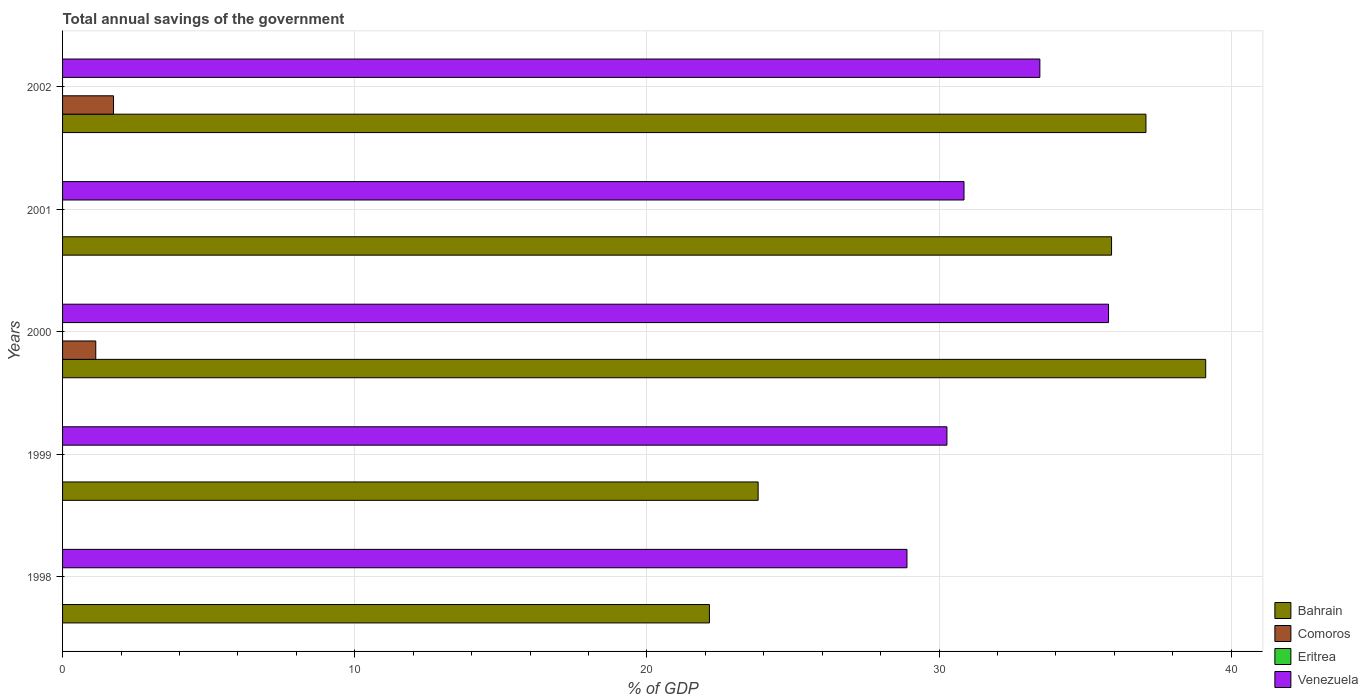How many different coloured bars are there?
Give a very brief answer. 3. How many groups of bars are there?
Your answer should be compact. 5. How many bars are there on the 4th tick from the bottom?
Ensure brevity in your answer.  2. What is the label of the 5th group of bars from the top?
Your answer should be very brief. 1998. In how many cases, is the number of bars for a given year not equal to the number of legend labels?
Your response must be concise. 5. What is the total annual savings of the government in Comoros in 2002?
Keep it short and to the point. 1.74. Across all years, what is the maximum total annual savings of the government in Comoros?
Give a very brief answer. 1.74. What is the total total annual savings of the government in Venezuela in the graph?
Provide a succinct answer. 159.28. What is the difference between the total annual savings of the government in Venezuela in 1998 and that in 2002?
Offer a very short reply. -4.55. What is the difference between the total annual savings of the government in Comoros in 1998 and the total annual savings of the government in Venezuela in 2002?
Provide a succinct answer. -33.45. What is the average total annual savings of the government in Bahrain per year?
Offer a terse response. 31.61. In the year 2000, what is the difference between the total annual savings of the government in Comoros and total annual savings of the government in Venezuela?
Offer a terse response. -34.67. In how many years, is the total annual savings of the government in Venezuela greater than 20 %?
Provide a short and direct response. 5. What is the ratio of the total annual savings of the government in Bahrain in 1998 to that in 2000?
Your answer should be compact. 0.57. What is the difference between the highest and the second highest total annual savings of the government in Bahrain?
Provide a short and direct response. 2.05. What is the difference between the highest and the lowest total annual savings of the government in Venezuela?
Make the answer very short. 6.9. In how many years, is the total annual savings of the government in Comoros greater than the average total annual savings of the government in Comoros taken over all years?
Give a very brief answer. 2. Is it the case that in every year, the sum of the total annual savings of the government in Comoros and total annual savings of the government in Eritrea is greater than the sum of total annual savings of the government in Bahrain and total annual savings of the government in Venezuela?
Offer a terse response. No. How many bars are there?
Offer a terse response. 12. How many years are there in the graph?
Your answer should be very brief. 5. Does the graph contain any zero values?
Keep it short and to the point. Yes. Does the graph contain grids?
Offer a terse response. Yes. Where does the legend appear in the graph?
Keep it short and to the point. Bottom right. How are the legend labels stacked?
Your response must be concise. Vertical. What is the title of the graph?
Your answer should be very brief. Total annual savings of the government. Does "Central Europe" appear as one of the legend labels in the graph?
Give a very brief answer. No. What is the label or title of the X-axis?
Offer a very short reply. % of GDP. What is the % of GDP in Bahrain in 1998?
Provide a short and direct response. 22.14. What is the % of GDP in Comoros in 1998?
Offer a terse response. 0. What is the % of GDP of Venezuela in 1998?
Your answer should be compact. 28.9. What is the % of GDP of Bahrain in 1999?
Provide a succinct answer. 23.81. What is the % of GDP in Comoros in 1999?
Offer a very short reply. 0. What is the % of GDP of Eritrea in 1999?
Your response must be concise. 0. What is the % of GDP in Venezuela in 1999?
Give a very brief answer. 30.27. What is the % of GDP of Bahrain in 2000?
Offer a terse response. 39.13. What is the % of GDP of Comoros in 2000?
Your answer should be very brief. 1.14. What is the % of GDP of Eritrea in 2000?
Your response must be concise. 0. What is the % of GDP in Venezuela in 2000?
Your answer should be compact. 35.8. What is the % of GDP of Bahrain in 2001?
Give a very brief answer. 35.9. What is the % of GDP of Eritrea in 2001?
Offer a very short reply. 0. What is the % of GDP in Venezuela in 2001?
Provide a succinct answer. 30.85. What is the % of GDP of Bahrain in 2002?
Ensure brevity in your answer.  37.08. What is the % of GDP in Comoros in 2002?
Offer a very short reply. 1.74. What is the % of GDP in Venezuela in 2002?
Your response must be concise. 33.45. Across all years, what is the maximum % of GDP of Bahrain?
Provide a short and direct response. 39.13. Across all years, what is the maximum % of GDP in Comoros?
Provide a short and direct response. 1.74. Across all years, what is the maximum % of GDP of Venezuela?
Ensure brevity in your answer.  35.8. Across all years, what is the minimum % of GDP in Bahrain?
Provide a succinct answer. 22.14. Across all years, what is the minimum % of GDP in Comoros?
Offer a terse response. 0. Across all years, what is the minimum % of GDP in Venezuela?
Ensure brevity in your answer.  28.9. What is the total % of GDP of Bahrain in the graph?
Provide a succinct answer. 158.06. What is the total % of GDP in Comoros in the graph?
Your answer should be compact. 2.88. What is the total % of GDP in Venezuela in the graph?
Offer a terse response. 159.28. What is the difference between the % of GDP of Bahrain in 1998 and that in 1999?
Your answer should be very brief. -1.67. What is the difference between the % of GDP of Venezuela in 1998 and that in 1999?
Your answer should be compact. -1.37. What is the difference between the % of GDP of Bahrain in 1998 and that in 2000?
Your answer should be very brief. -16.99. What is the difference between the % of GDP in Venezuela in 1998 and that in 2000?
Keep it short and to the point. -6.9. What is the difference between the % of GDP in Bahrain in 1998 and that in 2001?
Ensure brevity in your answer.  -13.76. What is the difference between the % of GDP in Venezuela in 1998 and that in 2001?
Offer a very short reply. -1.95. What is the difference between the % of GDP in Bahrain in 1998 and that in 2002?
Keep it short and to the point. -14.94. What is the difference between the % of GDP of Venezuela in 1998 and that in 2002?
Your answer should be compact. -4.55. What is the difference between the % of GDP in Bahrain in 1999 and that in 2000?
Your answer should be compact. -15.32. What is the difference between the % of GDP of Venezuela in 1999 and that in 2000?
Keep it short and to the point. -5.53. What is the difference between the % of GDP in Bahrain in 1999 and that in 2001?
Offer a very short reply. -12.1. What is the difference between the % of GDP of Venezuela in 1999 and that in 2001?
Your answer should be very brief. -0.58. What is the difference between the % of GDP of Bahrain in 1999 and that in 2002?
Your answer should be compact. -13.27. What is the difference between the % of GDP of Venezuela in 1999 and that in 2002?
Your response must be concise. -3.18. What is the difference between the % of GDP of Bahrain in 2000 and that in 2001?
Your answer should be compact. 3.22. What is the difference between the % of GDP of Venezuela in 2000 and that in 2001?
Ensure brevity in your answer.  4.95. What is the difference between the % of GDP of Bahrain in 2000 and that in 2002?
Provide a short and direct response. 2.05. What is the difference between the % of GDP of Comoros in 2000 and that in 2002?
Offer a very short reply. -0.61. What is the difference between the % of GDP in Venezuela in 2000 and that in 2002?
Provide a succinct answer. 2.35. What is the difference between the % of GDP of Bahrain in 2001 and that in 2002?
Give a very brief answer. -1.18. What is the difference between the % of GDP in Venezuela in 2001 and that in 2002?
Provide a short and direct response. -2.6. What is the difference between the % of GDP in Bahrain in 1998 and the % of GDP in Venezuela in 1999?
Give a very brief answer. -8.13. What is the difference between the % of GDP in Bahrain in 1998 and the % of GDP in Comoros in 2000?
Provide a short and direct response. 21. What is the difference between the % of GDP of Bahrain in 1998 and the % of GDP of Venezuela in 2000?
Provide a short and direct response. -13.66. What is the difference between the % of GDP of Bahrain in 1998 and the % of GDP of Venezuela in 2001?
Your answer should be compact. -8.71. What is the difference between the % of GDP of Bahrain in 1998 and the % of GDP of Comoros in 2002?
Ensure brevity in your answer.  20.4. What is the difference between the % of GDP in Bahrain in 1998 and the % of GDP in Venezuela in 2002?
Provide a short and direct response. -11.31. What is the difference between the % of GDP of Bahrain in 1999 and the % of GDP of Comoros in 2000?
Offer a very short reply. 22.67. What is the difference between the % of GDP of Bahrain in 1999 and the % of GDP of Venezuela in 2000?
Provide a succinct answer. -11.99. What is the difference between the % of GDP in Bahrain in 1999 and the % of GDP in Venezuela in 2001?
Your answer should be very brief. -7.05. What is the difference between the % of GDP in Bahrain in 1999 and the % of GDP in Comoros in 2002?
Offer a very short reply. 22.06. What is the difference between the % of GDP of Bahrain in 1999 and the % of GDP of Venezuela in 2002?
Offer a very short reply. -9.64. What is the difference between the % of GDP in Bahrain in 2000 and the % of GDP in Venezuela in 2001?
Provide a succinct answer. 8.27. What is the difference between the % of GDP in Comoros in 2000 and the % of GDP in Venezuela in 2001?
Offer a very short reply. -29.72. What is the difference between the % of GDP of Bahrain in 2000 and the % of GDP of Comoros in 2002?
Offer a terse response. 37.38. What is the difference between the % of GDP in Bahrain in 2000 and the % of GDP in Venezuela in 2002?
Give a very brief answer. 5.68. What is the difference between the % of GDP of Comoros in 2000 and the % of GDP of Venezuela in 2002?
Keep it short and to the point. -32.31. What is the difference between the % of GDP in Bahrain in 2001 and the % of GDP in Comoros in 2002?
Make the answer very short. 34.16. What is the difference between the % of GDP in Bahrain in 2001 and the % of GDP in Venezuela in 2002?
Your response must be concise. 2.45. What is the average % of GDP in Bahrain per year?
Provide a succinct answer. 31.61. What is the average % of GDP in Comoros per year?
Your response must be concise. 0.58. What is the average % of GDP in Venezuela per year?
Make the answer very short. 31.86. In the year 1998, what is the difference between the % of GDP of Bahrain and % of GDP of Venezuela?
Your answer should be compact. -6.76. In the year 1999, what is the difference between the % of GDP in Bahrain and % of GDP in Venezuela?
Keep it short and to the point. -6.46. In the year 2000, what is the difference between the % of GDP of Bahrain and % of GDP of Comoros?
Ensure brevity in your answer.  37.99. In the year 2000, what is the difference between the % of GDP of Bahrain and % of GDP of Venezuela?
Ensure brevity in your answer.  3.33. In the year 2000, what is the difference between the % of GDP in Comoros and % of GDP in Venezuela?
Your answer should be very brief. -34.67. In the year 2001, what is the difference between the % of GDP of Bahrain and % of GDP of Venezuela?
Offer a very short reply. 5.05. In the year 2002, what is the difference between the % of GDP of Bahrain and % of GDP of Comoros?
Your answer should be very brief. 35.34. In the year 2002, what is the difference between the % of GDP in Bahrain and % of GDP in Venezuela?
Make the answer very short. 3.63. In the year 2002, what is the difference between the % of GDP of Comoros and % of GDP of Venezuela?
Your response must be concise. -31.71. What is the ratio of the % of GDP of Bahrain in 1998 to that in 1999?
Your answer should be very brief. 0.93. What is the ratio of the % of GDP of Venezuela in 1998 to that in 1999?
Provide a short and direct response. 0.95. What is the ratio of the % of GDP in Bahrain in 1998 to that in 2000?
Your answer should be very brief. 0.57. What is the ratio of the % of GDP in Venezuela in 1998 to that in 2000?
Offer a very short reply. 0.81. What is the ratio of the % of GDP of Bahrain in 1998 to that in 2001?
Provide a short and direct response. 0.62. What is the ratio of the % of GDP in Venezuela in 1998 to that in 2001?
Give a very brief answer. 0.94. What is the ratio of the % of GDP of Bahrain in 1998 to that in 2002?
Ensure brevity in your answer.  0.6. What is the ratio of the % of GDP of Venezuela in 1998 to that in 2002?
Your answer should be compact. 0.86. What is the ratio of the % of GDP of Bahrain in 1999 to that in 2000?
Provide a succinct answer. 0.61. What is the ratio of the % of GDP in Venezuela in 1999 to that in 2000?
Ensure brevity in your answer.  0.85. What is the ratio of the % of GDP in Bahrain in 1999 to that in 2001?
Provide a short and direct response. 0.66. What is the ratio of the % of GDP of Venezuela in 1999 to that in 2001?
Ensure brevity in your answer.  0.98. What is the ratio of the % of GDP of Bahrain in 1999 to that in 2002?
Offer a very short reply. 0.64. What is the ratio of the % of GDP in Venezuela in 1999 to that in 2002?
Offer a terse response. 0.9. What is the ratio of the % of GDP of Bahrain in 2000 to that in 2001?
Make the answer very short. 1.09. What is the ratio of the % of GDP in Venezuela in 2000 to that in 2001?
Ensure brevity in your answer.  1.16. What is the ratio of the % of GDP in Bahrain in 2000 to that in 2002?
Your answer should be very brief. 1.06. What is the ratio of the % of GDP in Comoros in 2000 to that in 2002?
Give a very brief answer. 0.65. What is the ratio of the % of GDP in Venezuela in 2000 to that in 2002?
Offer a very short reply. 1.07. What is the ratio of the % of GDP in Bahrain in 2001 to that in 2002?
Offer a terse response. 0.97. What is the ratio of the % of GDP of Venezuela in 2001 to that in 2002?
Offer a very short reply. 0.92. What is the difference between the highest and the second highest % of GDP of Bahrain?
Your response must be concise. 2.05. What is the difference between the highest and the second highest % of GDP of Venezuela?
Keep it short and to the point. 2.35. What is the difference between the highest and the lowest % of GDP in Bahrain?
Provide a succinct answer. 16.99. What is the difference between the highest and the lowest % of GDP in Comoros?
Provide a short and direct response. 1.74. What is the difference between the highest and the lowest % of GDP of Venezuela?
Your answer should be compact. 6.9. 